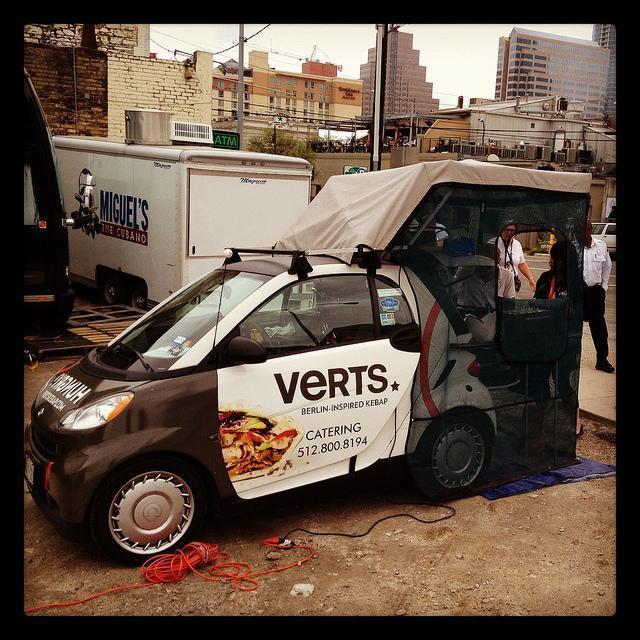How many people are in the picture?
Give a very brief answer. 3. How many elephants are in the picture?
Give a very brief answer. 0. 